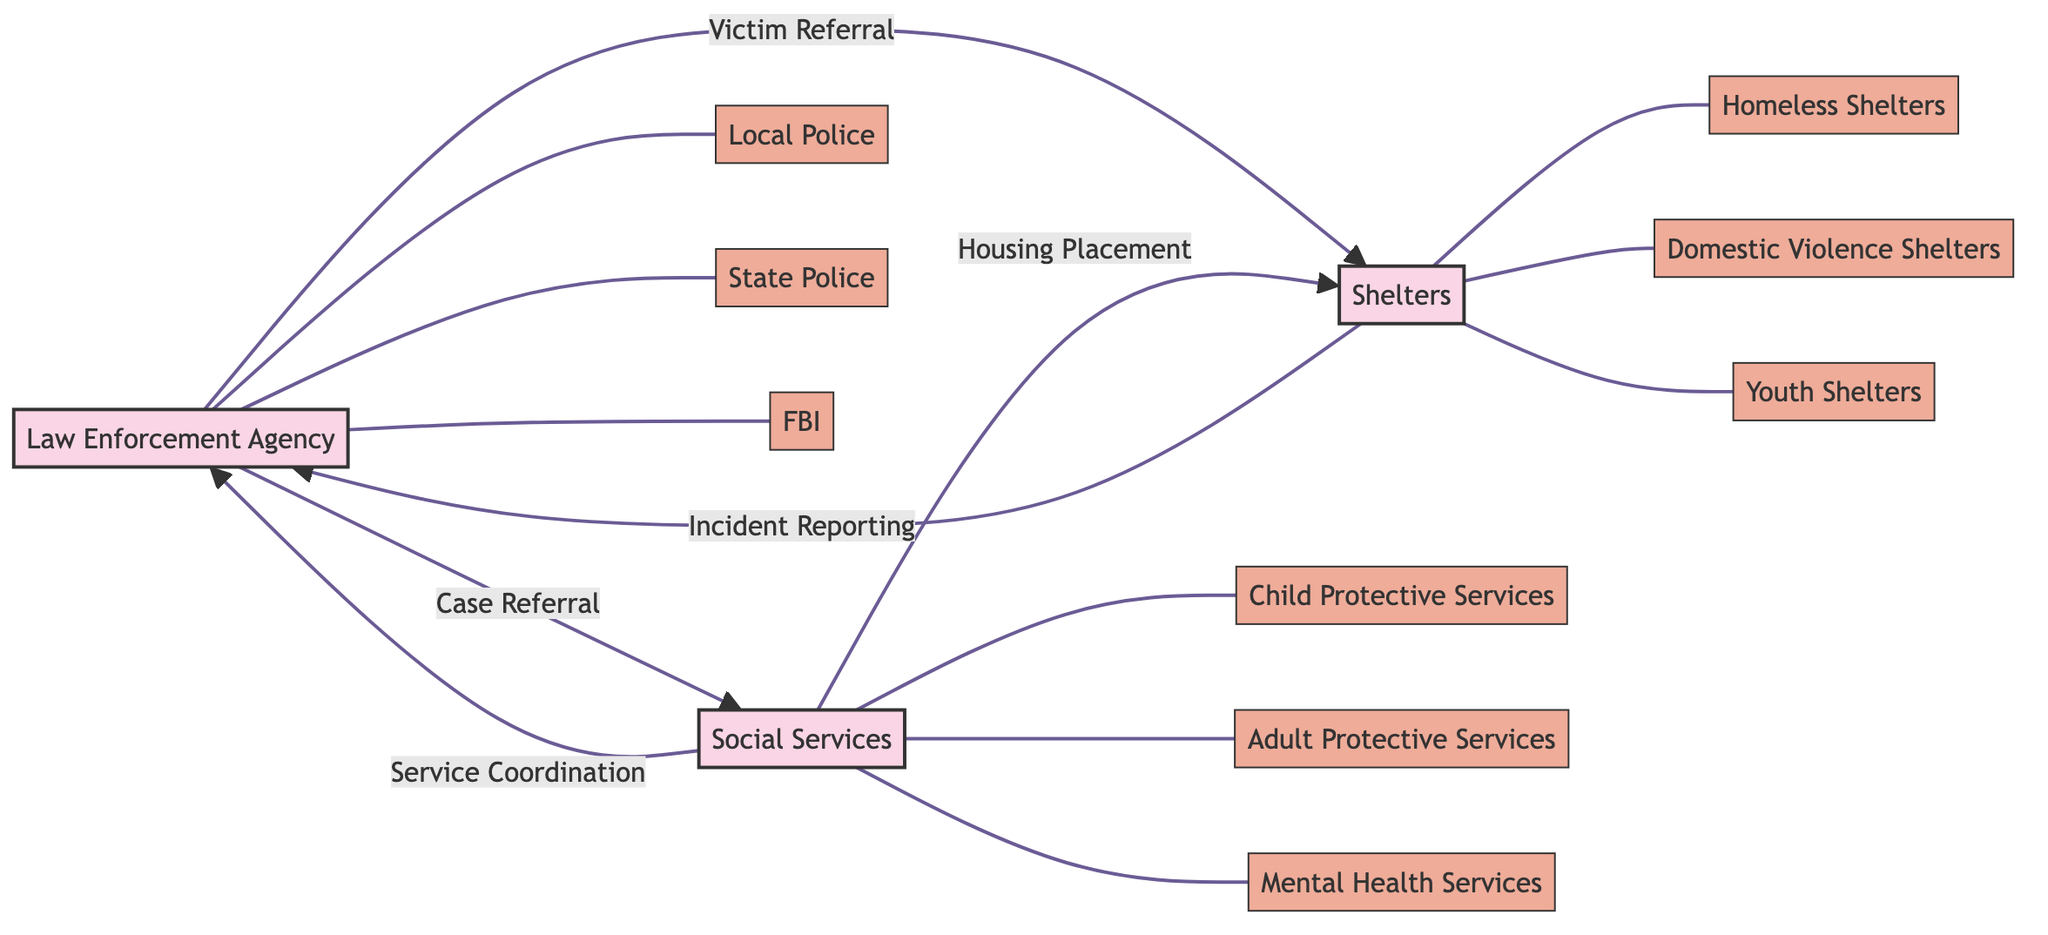What are the three departments under Law Enforcement Agency? The diagram indicates that under the Law Enforcement Agency, there are three departments listed: Local Police, State Police, and FBI.
Answer: Local Police, State Police, FBI How many edges are there in total? The diagram shows connections (or edges) between nodes. Each connection indicates a communication channel. Counting these shows there are five connections in total: Law Enforcement Agency to Social Services, Law Enforcement Agency to Shelters, Social Services to Shelters, Shelters to Law Enforcement Agency, and Social Services to Law Enforcement Agency.
Answer: 5 What type of information flows from Shelters to Law Enforcement Agency? According to the diagram, the information flowing from Shelters to Law Enforcement Agency is categorized under an Incident Reporting channel. The specific types of information flow include Security Reports, Emergency Contacts, and Incident Logs.
Answer: Security Reports, Emergency Contacts, Incident Logs Which agency sends Case Files? The diagram shows that Case Files are sent from the Law Enforcement Agency to Social Services through the Case Referral channel.
Answer: Law Enforcement Agency How many types of information flow are represented in the connections? Evaluating the connections in the diagram reveals six distinct types of information flows: Case Files, Incident Reports, Risk Assessments, Victim Profiles, Protection Orders, Safety Plans, Eligibility Assessments, Service Plans, and Follow-up Reports. Therefore, there are a total of six types of information flow indicated in the diagram.
Answer: 6 What is the connection name between Social Services and Shelters? Reviewing the connections on the diagram identifies the channel between Social Services and Shelters as Housing Placement.
Answer: Housing Placement What agencies receive reports from Social Services? The diagram indicates that Social Services sends information to both the Law Enforcement Agency and Shelters. Therefore, these two agencies receive reports from Social Services.
Answer: Law Enforcement Agency, Shelters Which shelter type is connected to the Law Enforcement Agency? The diagram indicates that all three types of shelters (Homeless Shelters, Domestic Violence Shelters, and Youth Shelters) communicate with the Law Enforcement Agency through the Victim Referral and Incident Reporting channels. However, the question asks for one shelter type connected specifically; any of them suffices, but I will state Homeless Shelters for specificity.
Answer: Homeless Shelters Which agency is responsible for the Service Coordination? The diagram reveals that Service Coordination flows from Social Services to Law Enforcement Agency, indicating that Social Services is responsible for this channel.
Answer: Social Services 